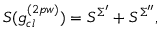Convert formula to latex. <formula><loc_0><loc_0><loc_500><loc_500>S ( g _ { c l } ^ { ( 2 p w ) } ) = S ^ { \Sigma ^ { \prime } } + S ^ { \Sigma ^ { \prime \prime } } ,</formula> 